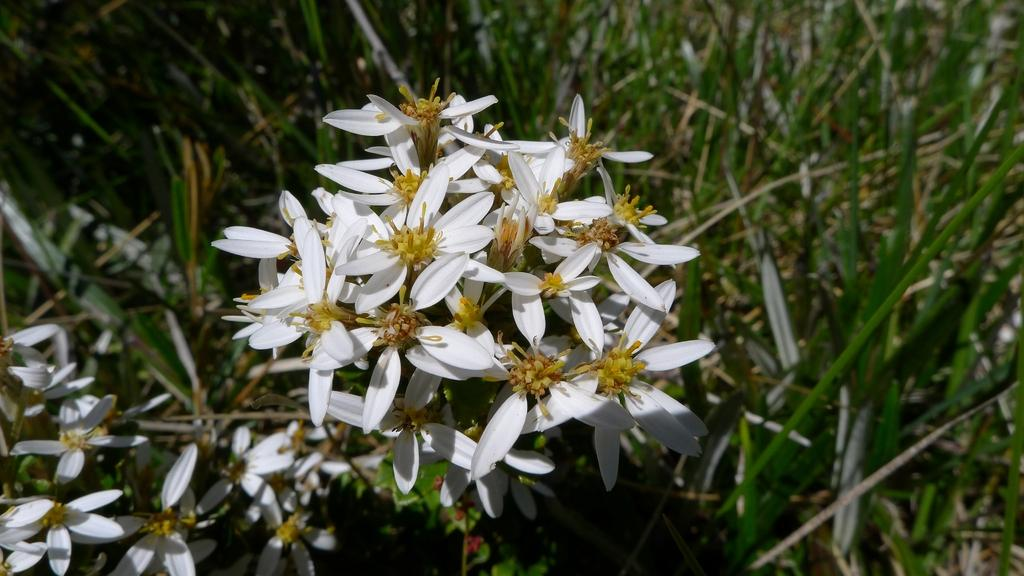What color are the flowers on the plants in the image? The flowers on the plants in the image are white. Can you hear the acoustics of the marble floor in the image? There is no mention of a marble floor in the image, and therefore no acoustics can be heard. 